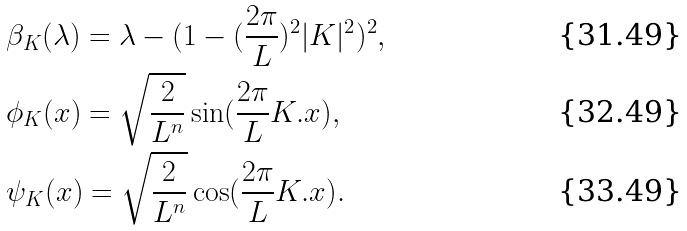Convert formula to latex. <formula><loc_0><loc_0><loc_500><loc_500>& \beta _ { K } ( \lambda ) = \lambda - ( 1 - ( \frac { 2 \pi } { L } ) ^ { 2 } | K | ^ { 2 } ) ^ { 2 } , \\ & \phi _ { K } ( x ) = \sqrt { \frac { 2 } { L ^ { n } } } \sin ( \frac { 2 \pi } { L } K . x ) , \\ & \psi _ { K } ( x ) = \sqrt { \frac { 2 } { L ^ { n } } } \cos ( \frac { 2 \pi } { L } K . x ) .</formula> 